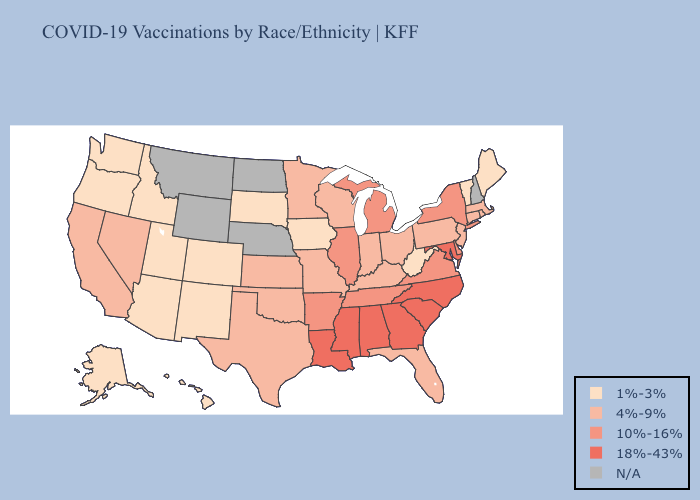Does Louisiana have the lowest value in the USA?
Answer briefly. No. Name the states that have a value in the range N/A?
Keep it brief. Montana, Nebraska, New Hampshire, North Dakota, Wyoming. Does Utah have the highest value in the USA?
Keep it brief. No. Does South Carolina have the highest value in the USA?
Concise answer only. Yes. Is the legend a continuous bar?
Short answer required. No. What is the lowest value in states that border Colorado?
Write a very short answer. 1%-3%. Which states have the lowest value in the MidWest?
Answer briefly. Iowa, South Dakota. Name the states that have a value in the range 18%-43%?
Answer briefly. Alabama, Georgia, Louisiana, Maryland, Mississippi, North Carolina, South Carolina. Name the states that have a value in the range 4%-9%?
Write a very short answer. California, Connecticut, Florida, Indiana, Kansas, Kentucky, Massachusetts, Minnesota, Missouri, Nevada, New Jersey, Ohio, Oklahoma, Pennsylvania, Rhode Island, Texas, Wisconsin. Name the states that have a value in the range 1%-3%?
Concise answer only. Alaska, Arizona, Colorado, Hawaii, Idaho, Iowa, Maine, New Mexico, Oregon, South Dakota, Utah, Vermont, Washington, West Virginia. How many symbols are there in the legend?
Write a very short answer. 5. Name the states that have a value in the range 1%-3%?
Short answer required. Alaska, Arizona, Colorado, Hawaii, Idaho, Iowa, Maine, New Mexico, Oregon, South Dakota, Utah, Vermont, Washington, West Virginia. Does the map have missing data?
Give a very brief answer. Yes. Name the states that have a value in the range 18%-43%?
Short answer required. Alabama, Georgia, Louisiana, Maryland, Mississippi, North Carolina, South Carolina. What is the value of Michigan?
Answer briefly. 10%-16%. 